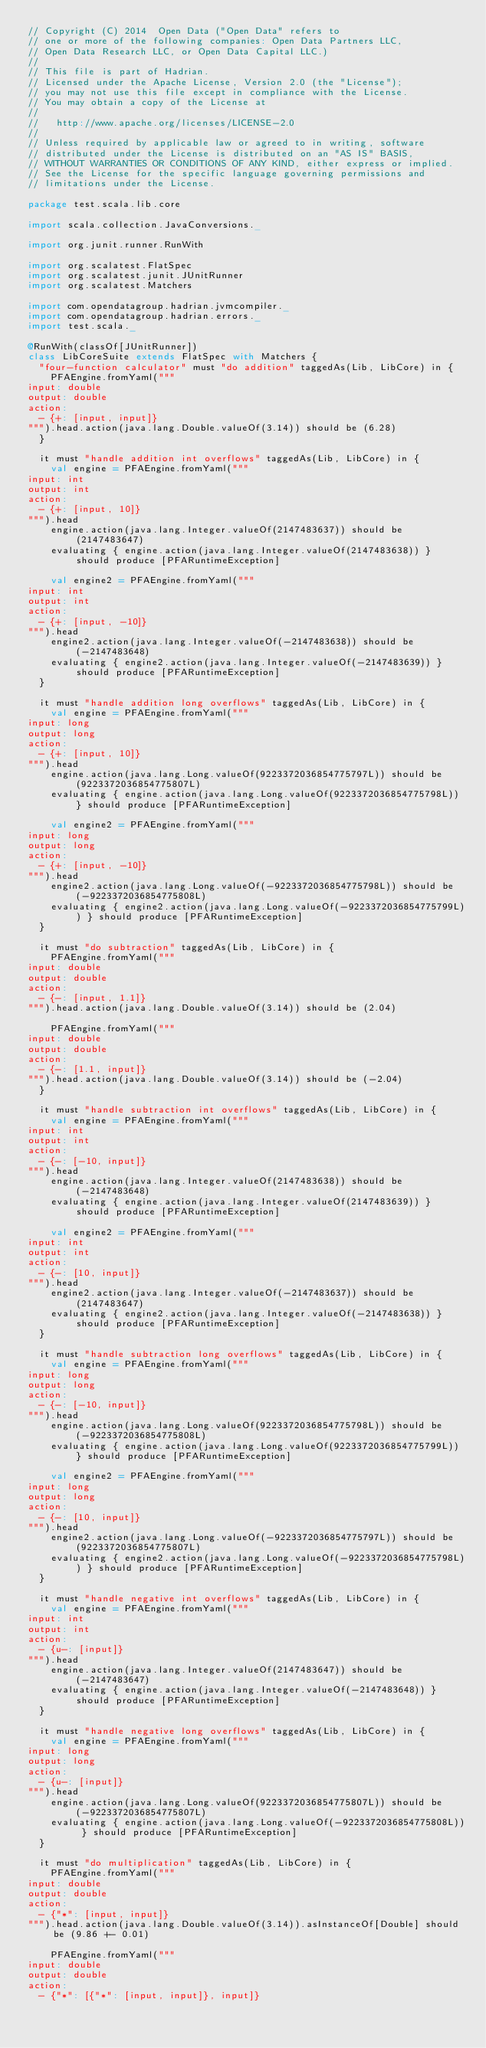Convert code to text. <code><loc_0><loc_0><loc_500><loc_500><_Scala_>// Copyright (C) 2014  Open Data ("Open Data" refers to
// one or more of the following companies: Open Data Partners LLC,
// Open Data Research LLC, or Open Data Capital LLC.)
// 
// This file is part of Hadrian.
// Licensed under the Apache License, Version 2.0 (the "License");
// you may not use this file except in compliance with the License.
// You may obtain a copy of the License at
//
//   http://www.apache.org/licenses/LICENSE-2.0
//
// Unless required by applicable law or agreed to in writing, software
// distributed under the License is distributed on an "AS IS" BASIS,
// WITHOUT WARRANTIES OR CONDITIONS OF ANY KIND, either express or implied.
// See the License for the specific language governing permissions and
// limitations under the License.

package test.scala.lib.core

import scala.collection.JavaConversions._

import org.junit.runner.RunWith

import org.scalatest.FlatSpec
import org.scalatest.junit.JUnitRunner
import org.scalatest.Matchers

import com.opendatagroup.hadrian.jvmcompiler._
import com.opendatagroup.hadrian.errors._
import test.scala._

@RunWith(classOf[JUnitRunner])
class LibCoreSuite extends FlatSpec with Matchers {
  "four-function calculator" must "do addition" taggedAs(Lib, LibCore) in {
    PFAEngine.fromYaml("""
input: double
output: double
action:
  - {+: [input, input]}
""").head.action(java.lang.Double.valueOf(3.14)) should be (6.28)
  }

  it must "handle addition int overflows" taggedAs(Lib, LibCore) in {
    val engine = PFAEngine.fromYaml("""
input: int
output: int
action:
  - {+: [input, 10]}
""").head
    engine.action(java.lang.Integer.valueOf(2147483637)) should be (2147483647)
    evaluating { engine.action(java.lang.Integer.valueOf(2147483638)) } should produce [PFARuntimeException]

    val engine2 = PFAEngine.fromYaml("""
input: int
output: int
action:
  - {+: [input, -10]}
""").head
    engine2.action(java.lang.Integer.valueOf(-2147483638)) should be (-2147483648)
    evaluating { engine2.action(java.lang.Integer.valueOf(-2147483639)) } should produce [PFARuntimeException]
  }

  it must "handle addition long overflows" taggedAs(Lib, LibCore) in {
    val engine = PFAEngine.fromYaml("""
input: long
output: long
action:
  - {+: [input, 10]}
""").head
    engine.action(java.lang.Long.valueOf(9223372036854775797L)) should be (9223372036854775807L)
    evaluating { engine.action(java.lang.Long.valueOf(9223372036854775798L)) } should produce [PFARuntimeException]

    val engine2 = PFAEngine.fromYaml("""
input: long
output: long
action:
  - {+: [input, -10]}
""").head
    engine2.action(java.lang.Long.valueOf(-9223372036854775798L)) should be (-9223372036854775808L)
    evaluating { engine2.action(java.lang.Long.valueOf(-9223372036854775799L)) } should produce [PFARuntimeException]
  }

  it must "do subtraction" taggedAs(Lib, LibCore) in {
    PFAEngine.fromYaml("""
input: double
output: double
action:
  - {-: [input, 1.1]}
""").head.action(java.lang.Double.valueOf(3.14)) should be (2.04)

    PFAEngine.fromYaml("""
input: double
output: double
action:
  - {-: [1.1, input]}
""").head.action(java.lang.Double.valueOf(3.14)) should be (-2.04)
  }

  it must "handle subtraction int overflows" taggedAs(Lib, LibCore) in {
    val engine = PFAEngine.fromYaml("""
input: int
output: int
action:
  - {-: [-10, input]}
""").head
    engine.action(java.lang.Integer.valueOf(2147483638)) should be (-2147483648)
    evaluating { engine.action(java.lang.Integer.valueOf(2147483639)) } should produce [PFARuntimeException]

    val engine2 = PFAEngine.fromYaml("""
input: int
output: int
action:
  - {-: [10, input]}
""").head
    engine2.action(java.lang.Integer.valueOf(-2147483637)) should be (2147483647)
    evaluating { engine2.action(java.lang.Integer.valueOf(-2147483638)) } should produce [PFARuntimeException]
  }

  it must "handle subtraction long overflows" taggedAs(Lib, LibCore) in {
    val engine = PFAEngine.fromYaml("""
input: long
output: long
action:
  - {-: [-10, input]}
""").head
    engine.action(java.lang.Long.valueOf(9223372036854775798L)) should be (-9223372036854775808L)
    evaluating { engine.action(java.lang.Long.valueOf(9223372036854775799L)) } should produce [PFARuntimeException]

    val engine2 = PFAEngine.fromYaml("""
input: long
output: long
action:
  - {-: [10, input]}
""").head
    engine2.action(java.lang.Long.valueOf(-9223372036854775797L)) should be (9223372036854775807L)
    evaluating { engine2.action(java.lang.Long.valueOf(-9223372036854775798L)) } should produce [PFARuntimeException]
  }

  it must "handle negative int overflows" taggedAs(Lib, LibCore) in {
    val engine = PFAEngine.fromYaml("""
input: int
output: int
action:
  - {u-: [input]}
""").head
    engine.action(java.lang.Integer.valueOf(2147483647)) should be (-2147483647)
    evaluating { engine.action(java.lang.Integer.valueOf(-2147483648)) } should produce [PFARuntimeException]
  }

  it must "handle negative long overflows" taggedAs(Lib, LibCore) in {
    val engine = PFAEngine.fromYaml("""
input: long
output: long
action:
  - {u-: [input]}
""").head
    engine.action(java.lang.Long.valueOf(9223372036854775807L)) should be (-9223372036854775807L)
    evaluating { engine.action(java.lang.Long.valueOf(-9223372036854775808L)) } should produce [PFARuntimeException]
  }

  it must "do multiplication" taggedAs(Lib, LibCore) in {
    PFAEngine.fromYaml("""
input: double
output: double
action:
  - {"*": [input, input]}
""").head.action(java.lang.Double.valueOf(3.14)).asInstanceOf[Double] should be (9.86 +- 0.01)

    PFAEngine.fromYaml("""
input: double
output: double
action:
  - {"*": [{"*": [input, input]}, input]}</code> 